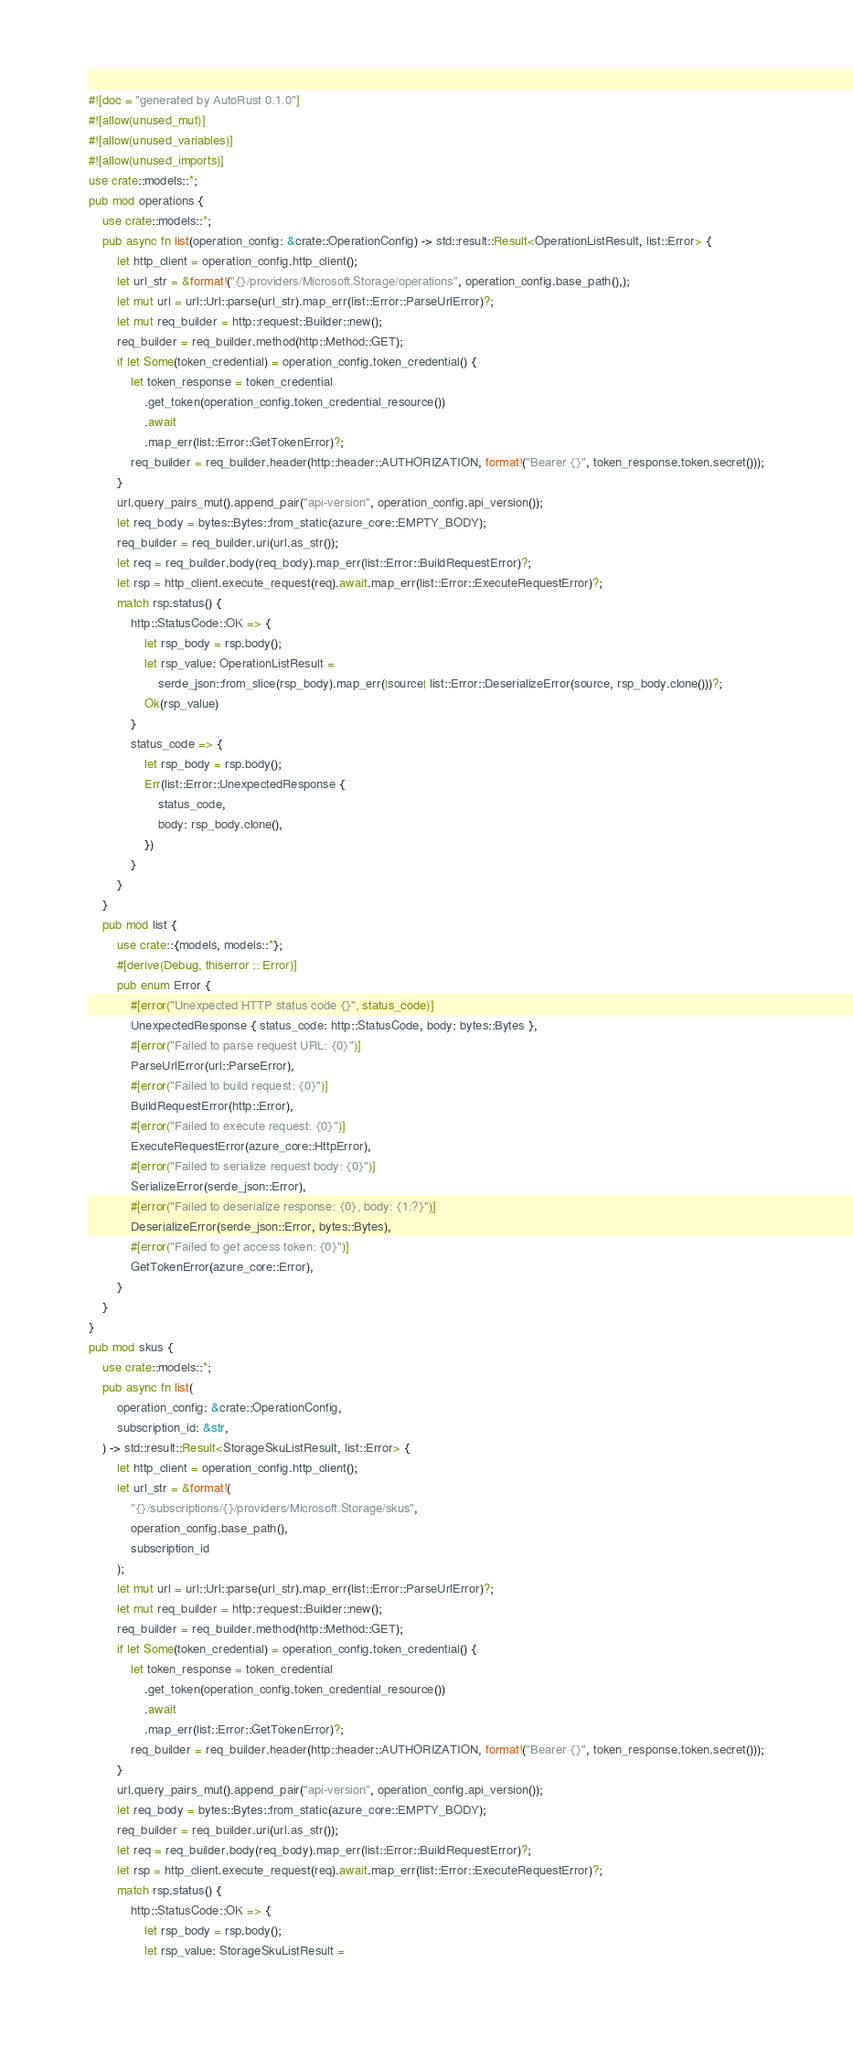Convert code to text. <code><loc_0><loc_0><loc_500><loc_500><_Rust_>#![doc = "generated by AutoRust 0.1.0"]
#![allow(unused_mut)]
#![allow(unused_variables)]
#![allow(unused_imports)]
use crate::models::*;
pub mod operations {
    use crate::models::*;
    pub async fn list(operation_config: &crate::OperationConfig) -> std::result::Result<OperationListResult, list::Error> {
        let http_client = operation_config.http_client();
        let url_str = &format!("{}/providers/Microsoft.Storage/operations", operation_config.base_path(),);
        let mut url = url::Url::parse(url_str).map_err(list::Error::ParseUrlError)?;
        let mut req_builder = http::request::Builder::new();
        req_builder = req_builder.method(http::Method::GET);
        if let Some(token_credential) = operation_config.token_credential() {
            let token_response = token_credential
                .get_token(operation_config.token_credential_resource())
                .await
                .map_err(list::Error::GetTokenError)?;
            req_builder = req_builder.header(http::header::AUTHORIZATION, format!("Bearer {}", token_response.token.secret()));
        }
        url.query_pairs_mut().append_pair("api-version", operation_config.api_version());
        let req_body = bytes::Bytes::from_static(azure_core::EMPTY_BODY);
        req_builder = req_builder.uri(url.as_str());
        let req = req_builder.body(req_body).map_err(list::Error::BuildRequestError)?;
        let rsp = http_client.execute_request(req).await.map_err(list::Error::ExecuteRequestError)?;
        match rsp.status() {
            http::StatusCode::OK => {
                let rsp_body = rsp.body();
                let rsp_value: OperationListResult =
                    serde_json::from_slice(rsp_body).map_err(|source| list::Error::DeserializeError(source, rsp_body.clone()))?;
                Ok(rsp_value)
            }
            status_code => {
                let rsp_body = rsp.body();
                Err(list::Error::UnexpectedResponse {
                    status_code,
                    body: rsp_body.clone(),
                })
            }
        }
    }
    pub mod list {
        use crate::{models, models::*};
        #[derive(Debug, thiserror :: Error)]
        pub enum Error {
            #[error("Unexpected HTTP status code {}", status_code)]
            UnexpectedResponse { status_code: http::StatusCode, body: bytes::Bytes },
            #[error("Failed to parse request URL: {0}")]
            ParseUrlError(url::ParseError),
            #[error("Failed to build request: {0}")]
            BuildRequestError(http::Error),
            #[error("Failed to execute request: {0}")]
            ExecuteRequestError(azure_core::HttpError),
            #[error("Failed to serialize request body: {0}")]
            SerializeError(serde_json::Error),
            #[error("Failed to deserialize response: {0}, body: {1:?}")]
            DeserializeError(serde_json::Error, bytes::Bytes),
            #[error("Failed to get access token: {0}")]
            GetTokenError(azure_core::Error),
        }
    }
}
pub mod skus {
    use crate::models::*;
    pub async fn list(
        operation_config: &crate::OperationConfig,
        subscription_id: &str,
    ) -> std::result::Result<StorageSkuListResult, list::Error> {
        let http_client = operation_config.http_client();
        let url_str = &format!(
            "{}/subscriptions/{}/providers/Microsoft.Storage/skus",
            operation_config.base_path(),
            subscription_id
        );
        let mut url = url::Url::parse(url_str).map_err(list::Error::ParseUrlError)?;
        let mut req_builder = http::request::Builder::new();
        req_builder = req_builder.method(http::Method::GET);
        if let Some(token_credential) = operation_config.token_credential() {
            let token_response = token_credential
                .get_token(operation_config.token_credential_resource())
                .await
                .map_err(list::Error::GetTokenError)?;
            req_builder = req_builder.header(http::header::AUTHORIZATION, format!("Bearer {}", token_response.token.secret()));
        }
        url.query_pairs_mut().append_pair("api-version", operation_config.api_version());
        let req_body = bytes::Bytes::from_static(azure_core::EMPTY_BODY);
        req_builder = req_builder.uri(url.as_str());
        let req = req_builder.body(req_body).map_err(list::Error::BuildRequestError)?;
        let rsp = http_client.execute_request(req).await.map_err(list::Error::ExecuteRequestError)?;
        match rsp.status() {
            http::StatusCode::OK => {
                let rsp_body = rsp.body();
                let rsp_value: StorageSkuListResult =</code> 